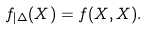Convert formula to latex. <formula><loc_0><loc_0><loc_500><loc_500>f _ { | \Delta } ( X ) = f ( X , X ) .</formula> 